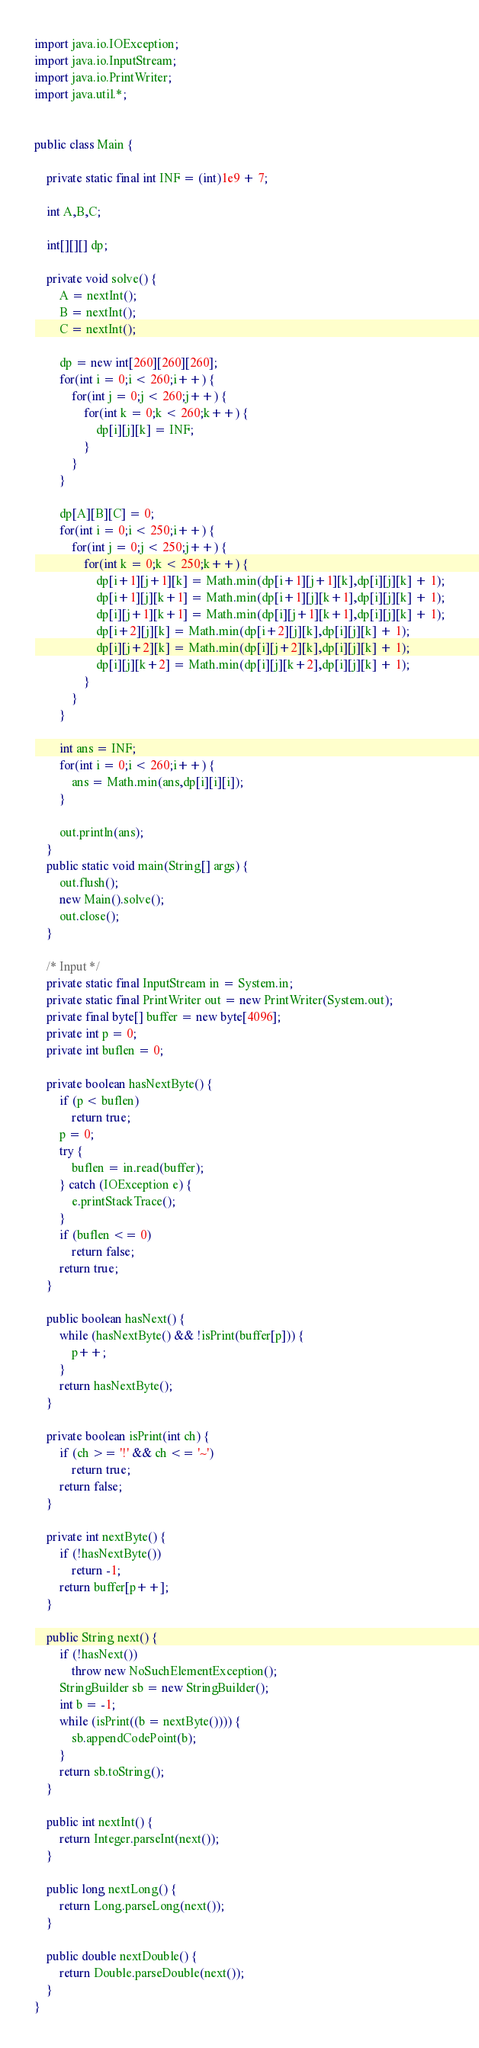<code> <loc_0><loc_0><loc_500><loc_500><_Java_>import java.io.IOException;
import java.io.InputStream;
import java.io.PrintWriter;
import java.util.*;


public class Main {

    private static final int INF = (int)1e9 + 7;

    int A,B,C;

    int[][][] dp;

    private void solve() {
        A = nextInt();
        B = nextInt();
        C = nextInt();

        dp = new int[260][260][260];
        for(int i = 0;i < 260;i++) {
            for(int j = 0;j < 260;j++) {
                for(int k = 0;k < 260;k++) {
                    dp[i][j][k] = INF;
                }
            }
        }

        dp[A][B][C] = 0;
        for(int i = 0;i < 250;i++) {
            for(int j = 0;j < 250;j++) {
                for(int k = 0;k < 250;k++) {
                    dp[i+1][j+1][k] = Math.min(dp[i+1][j+1][k],dp[i][j][k] + 1);
                    dp[i+1][j][k+1] = Math.min(dp[i+1][j][k+1],dp[i][j][k] + 1);
                    dp[i][j+1][k+1] = Math.min(dp[i][j+1][k+1],dp[i][j][k] + 1);
                    dp[i+2][j][k] = Math.min(dp[i+2][j][k],dp[i][j][k] + 1);
                    dp[i][j+2][k] = Math.min(dp[i][j+2][k],dp[i][j][k] + 1);
                    dp[i][j][k+2] = Math.min(dp[i][j][k+2],dp[i][j][k] + 1);
                }
            }
        }

        int ans = INF;
        for(int i = 0;i < 260;i++) {
            ans = Math.min(ans,dp[i][i][i]);
        }

        out.println(ans);
    }
    public static void main(String[] args) {
        out.flush();
        new Main().solve();
        out.close();
    }

    /* Input */
    private static final InputStream in = System.in;
    private static final PrintWriter out = new PrintWriter(System.out);
    private final byte[] buffer = new byte[4096];
    private int p = 0;
    private int buflen = 0;

    private boolean hasNextByte() {
        if (p < buflen)
            return true;
        p = 0;
        try {
            buflen = in.read(buffer);
        } catch (IOException e) {
            e.printStackTrace();
        }
        if (buflen <= 0)
            return false;
        return true;
    }

    public boolean hasNext() {
        while (hasNextByte() && !isPrint(buffer[p])) {
            p++;
        }
        return hasNextByte();
    }

    private boolean isPrint(int ch) {
        if (ch >= '!' && ch <= '~')
            return true;
        return false;
    }

    private int nextByte() {
        if (!hasNextByte())
            return -1;
        return buffer[p++];
    }

    public String next() {
        if (!hasNext())
            throw new NoSuchElementException();
        StringBuilder sb = new StringBuilder();
        int b = -1;
        while (isPrint((b = nextByte()))) {
            sb.appendCodePoint(b);
        }
        return sb.toString();
    }

    public int nextInt() {
        return Integer.parseInt(next());
    }

    public long nextLong() {
        return Long.parseLong(next());
    }

    public double nextDouble() {
        return Double.parseDouble(next());
    }
}</code> 